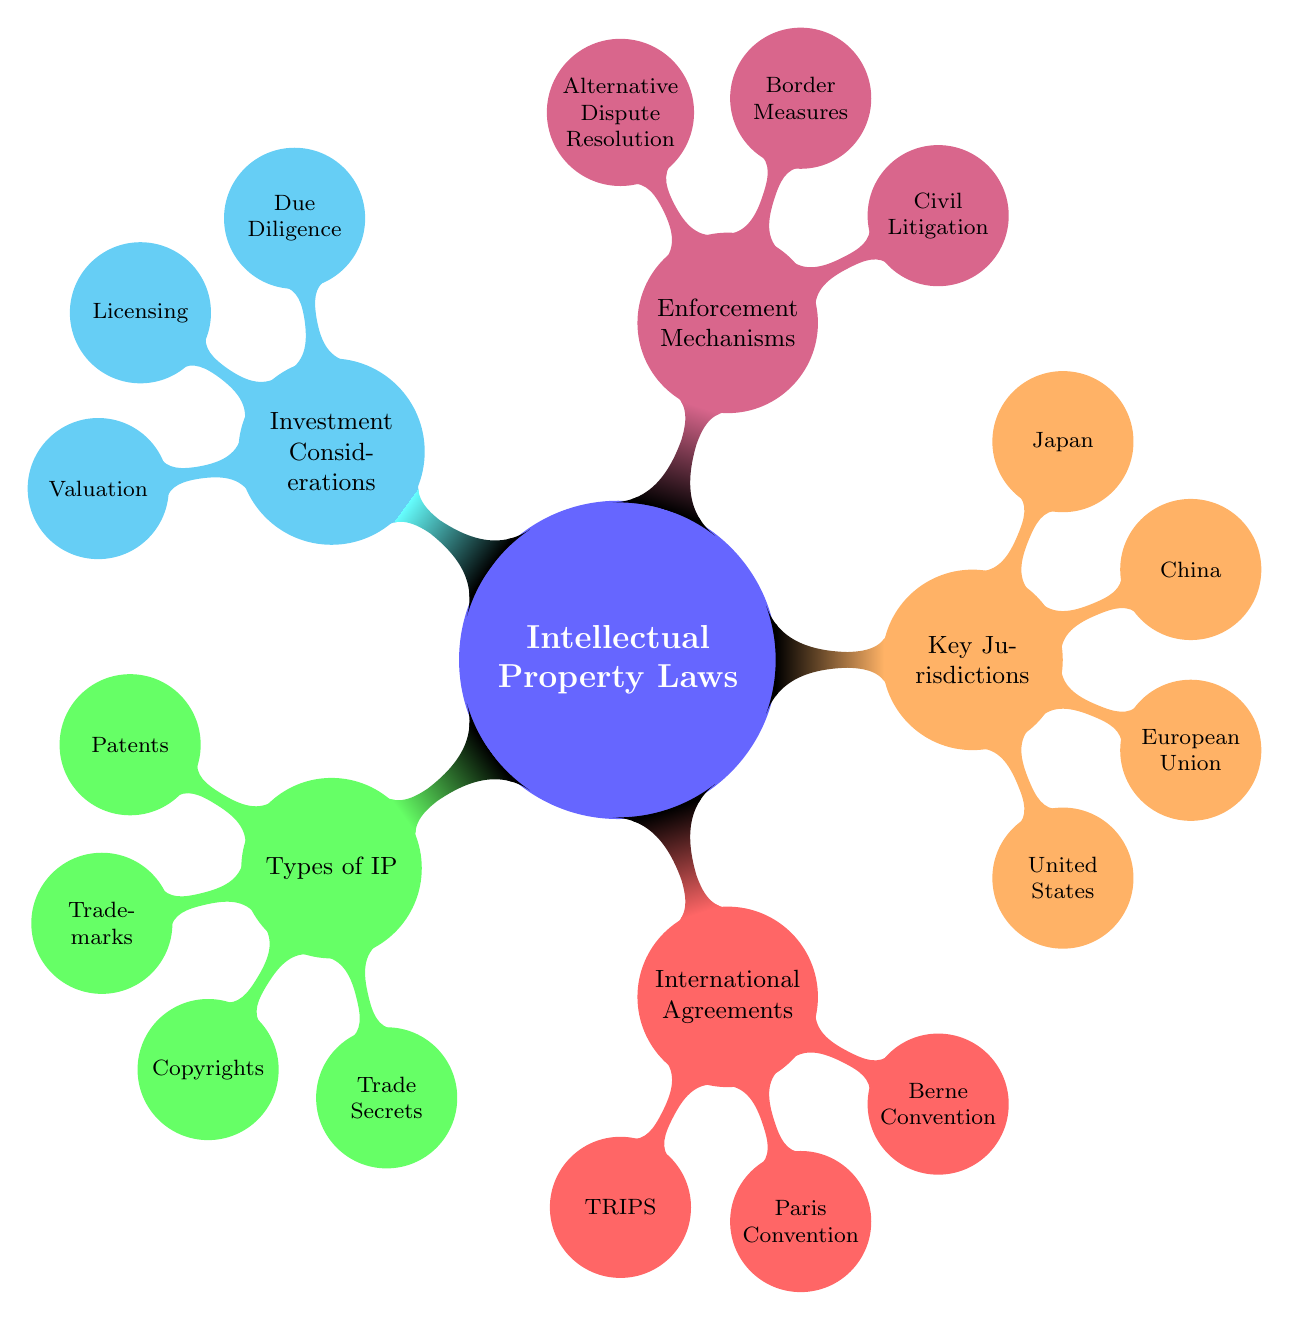What are the four types of intellectual property listed? The four types of intellectual property listed in the diagram are Patents, Trademarks, Copyrights, and Trade Secrets. This information is derived directly from the "Types of Intellectual Property" node in the diagram.
Answer: Patents, Trademarks, Copyrights, Trade Secrets Which jurisdiction is represented by the acronym USPTO? The acronym USPTO stands for the United States Patent and Trademark Office, which indicates that the United States is the corresponding jurisdiction under the "Key Jurisdictions" section of the diagram.
Answer: United States How many international agreements are mentioned in the diagram? The diagram lists three international agreements: TRIPS Agreement, Paris Convention, and Berne Convention. Counting these gives the total number of agreements.
Answer: 3 What legal mechanism involves suing for damages and injunctions? Civil Litigation is the legal mechanism described that involves suing for damages and seeking injunctions, as defined under the "Enforcement Mechanisms" section of the diagram.
Answer: Civil Litigation Which type of investment consideration involves assessing IP assets during business evaluations? Due Diligence is the investment consideration that involves assessing IP assets during business evaluations, as specified under the "Investment Considerations" node in the diagram.
Answer: Due Diligence Which two jurisdictions are focused on protecting industrial property and literary works? The Paris Convention focuses on protecting industrial property, while the Berne Convention focuses on protecting literary and artistic works, as indicated under "International Agreements."
Answer: Paris Convention, Berne Convention What is the purpose of border measures in the context of intellectual property laws? Border measures involve customs authorities blocking infringing goods, which is part of the enforcement mechanism detailed in the diagram. This reflects a strategy to prevent the unauthorized importation of patented or trademarked items.
Answer: Blocking infringing goods What are the three types of enforcement mechanisms listed? The diagram lists three enforcement mechanisms: Civil Litigation, Border Measures, and Alternative Dispute Resolution. These mechanisms are shown under "Enforcement Mechanisms" in the diagram.
Answer: Civil Litigation, Border Measures, Alternative Dispute Resolution What is one reason for licensing IP according to the diagram? The diagram indicates that licensing grants rights to use IP in new markets, suggesting that it allows expansion and use of intellectual property beyond its original context.
Answer: Rights granted to use IP in new markets 